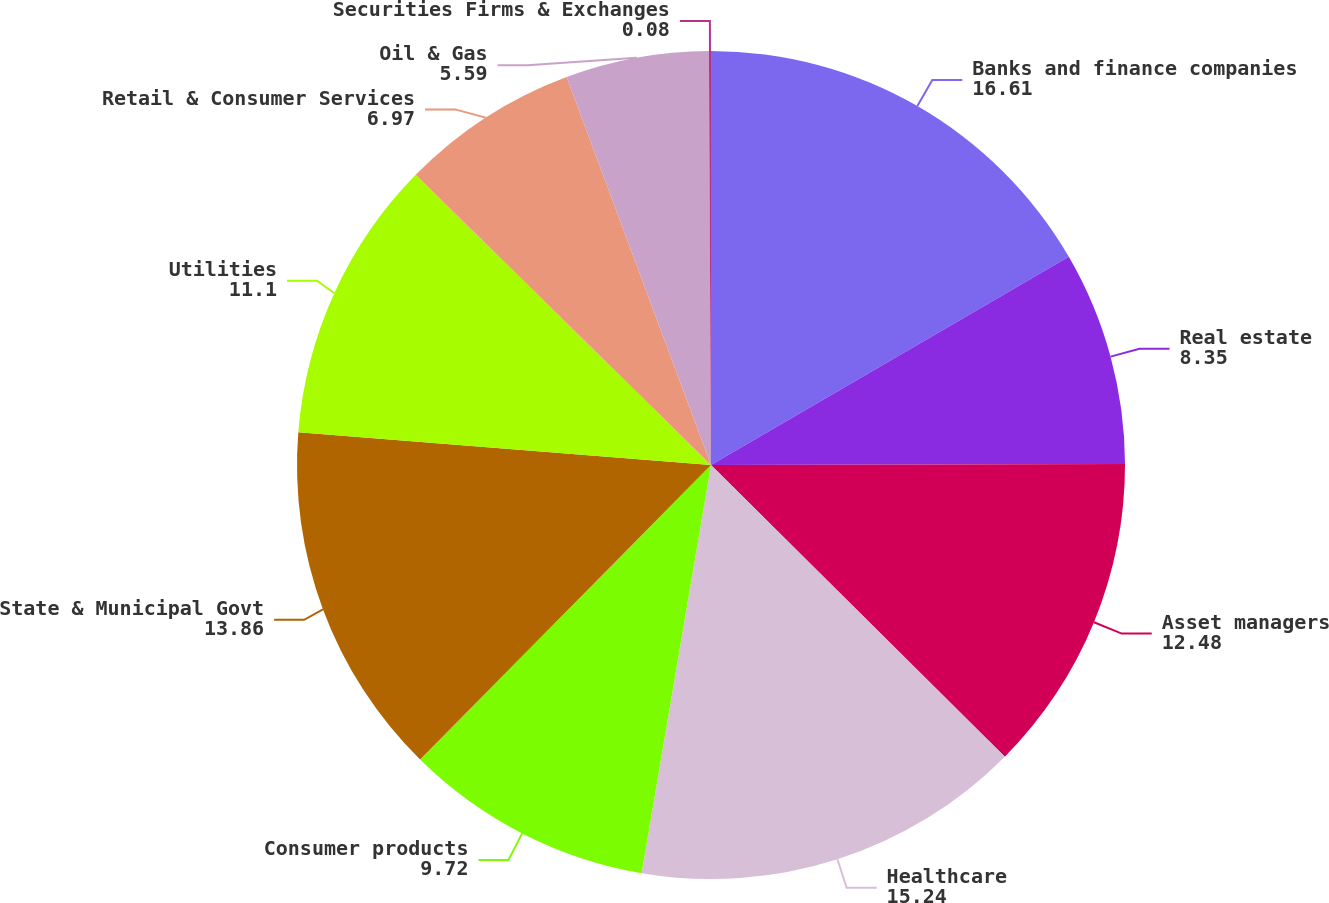<chart> <loc_0><loc_0><loc_500><loc_500><pie_chart><fcel>Banks and finance companies<fcel>Real estate<fcel>Asset managers<fcel>Healthcare<fcel>Consumer products<fcel>State & Municipal Govt<fcel>Utilities<fcel>Retail & Consumer Services<fcel>Oil & Gas<fcel>Securities Firms & Exchanges<nl><fcel>16.61%<fcel>8.35%<fcel>12.48%<fcel>15.24%<fcel>9.72%<fcel>13.86%<fcel>11.1%<fcel>6.97%<fcel>5.59%<fcel>0.08%<nl></chart> 